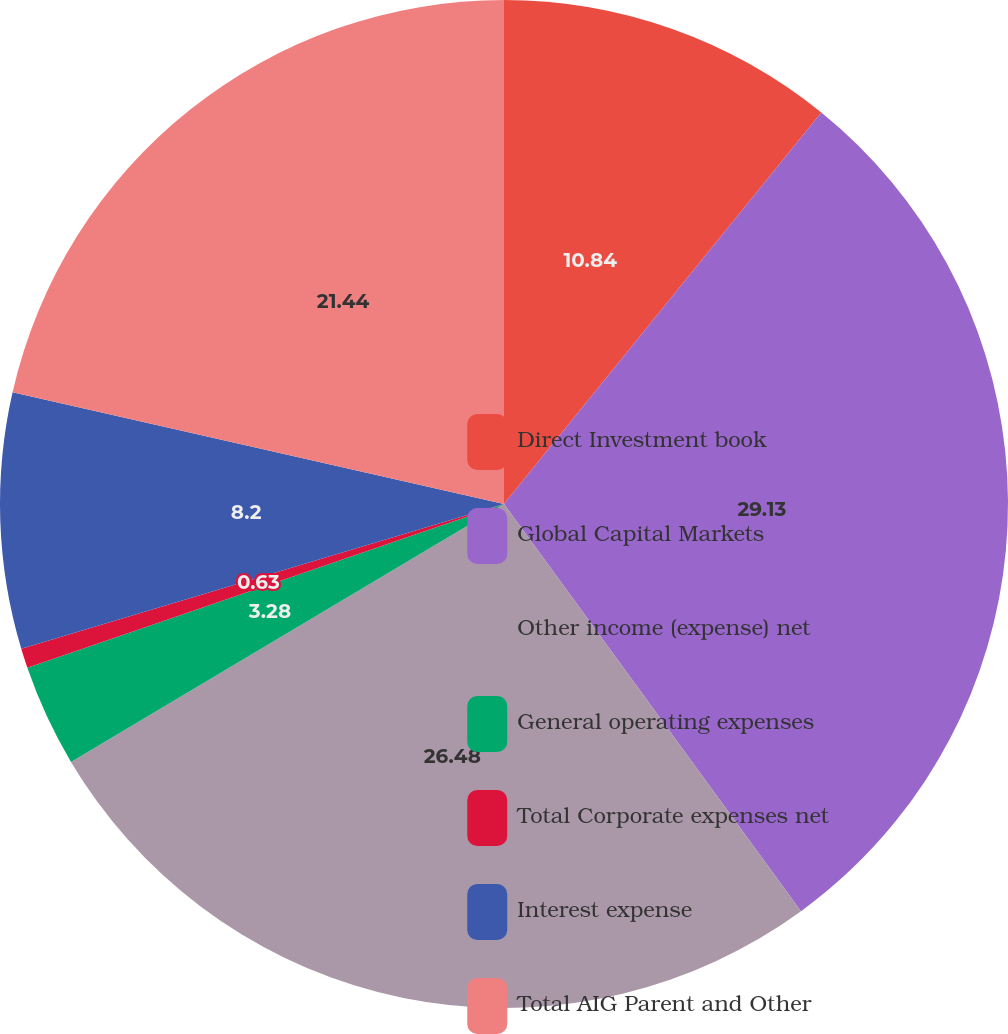<chart> <loc_0><loc_0><loc_500><loc_500><pie_chart><fcel>Direct Investment book<fcel>Global Capital Markets<fcel>Other income (expense) net<fcel>General operating expenses<fcel>Total Corporate expenses net<fcel>Interest expense<fcel>Total AIG Parent and Other<nl><fcel>10.84%<fcel>29.13%<fcel>26.48%<fcel>3.28%<fcel>0.63%<fcel>8.2%<fcel>21.44%<nl></chart> 